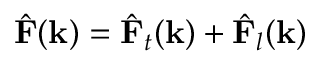<formula> <loc_0><loc_0><loc_500><loc_500>{ \hat { F } } ( k ) = { \hat { F } } _ { t } ( k ) + { \hat { F } } _ { l } ( k )</formula> 